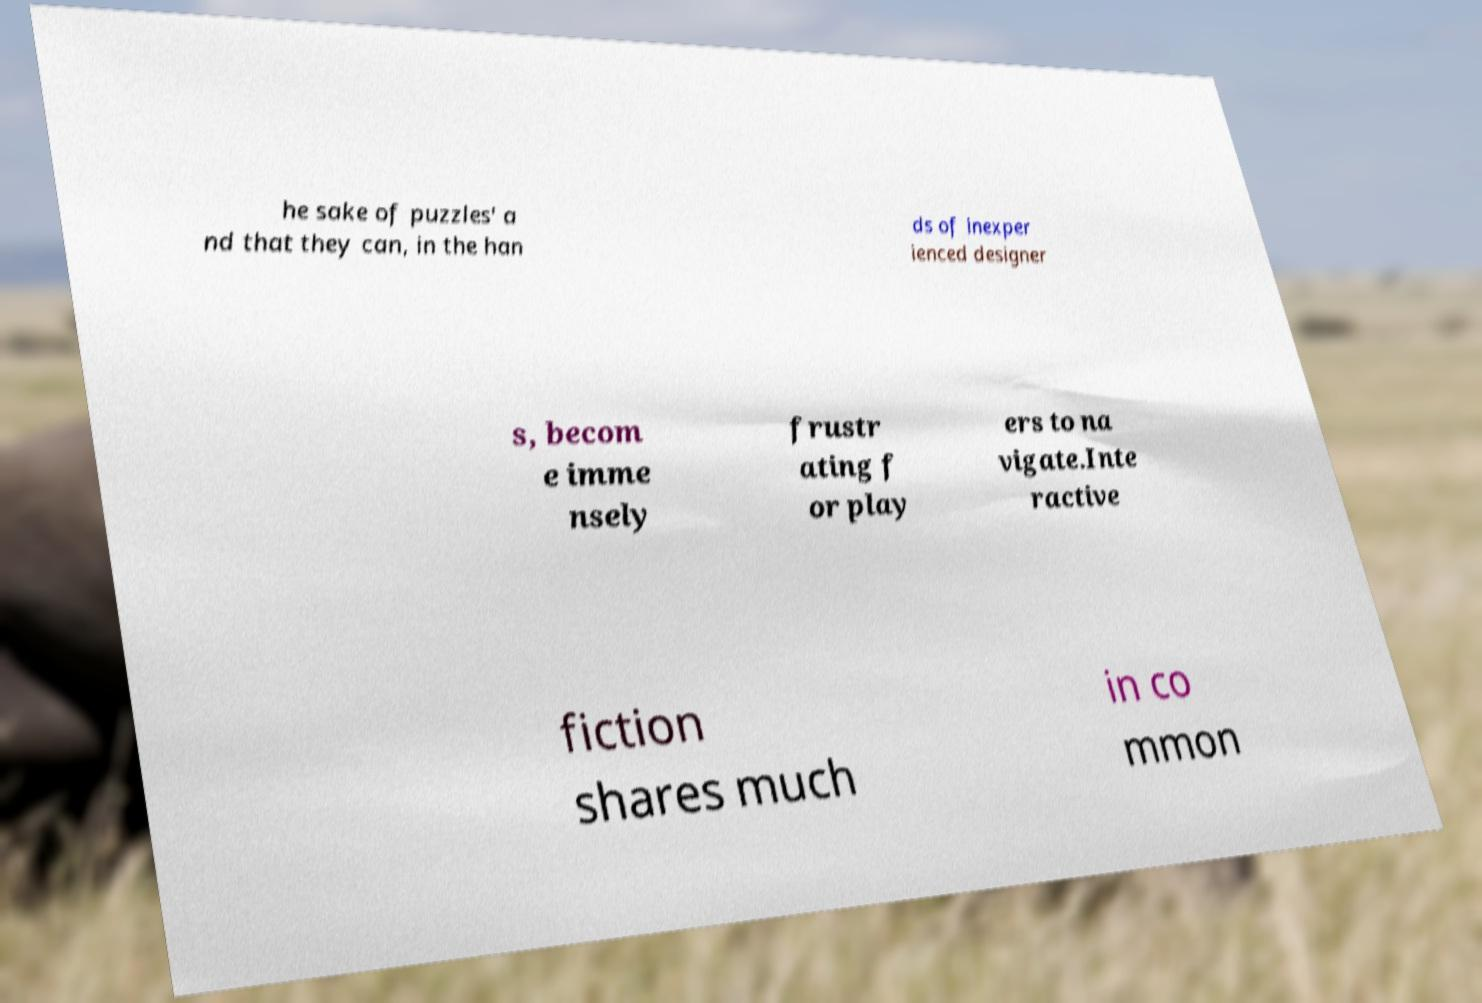Can you read and provide the text displayed in the image?This photo seems to have some interesting text. Can you extract and type it out for me? he sake of puzzles' a nd that they can, in the han ds of inexper ienced designer s, becom e imme nsely frustr ating f or play ers to na vigate.Inte ractive fiction shares much in co mmon 